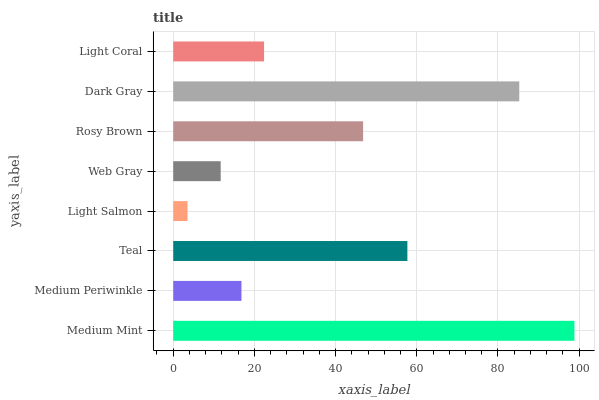Is Light Salmon the minimum?
Answer yes or no. Yes. Is Medium Mint the maximum?
Answer yes or no. Yes. Is Medium Periwinkle the minimum?
Answer yes or no. No. Is Medium Periwinkle the maximum?
Answer yes or no. No. Is Medium Mint greater than Medium Periwinkle?
Answer yes or no. Yes. Is Medium Periwinkle less than Medium Mint?
Answer yes or no. Yes. Is Medium Periwinkle greater than Medium Mint?
Answer yes or no. No. Is Medium Mint less than Medium Periwinkle?
Answer yes or no. No. Is Rosy Brown the high median?
Answer yes or no. Yes. Is Light Coral the low median?
Answer yes or no. Yes. Is Web Gray the high median?
Answer yes or no. No. Is Rosy Brown the low median?
Answer yes or no. No. 